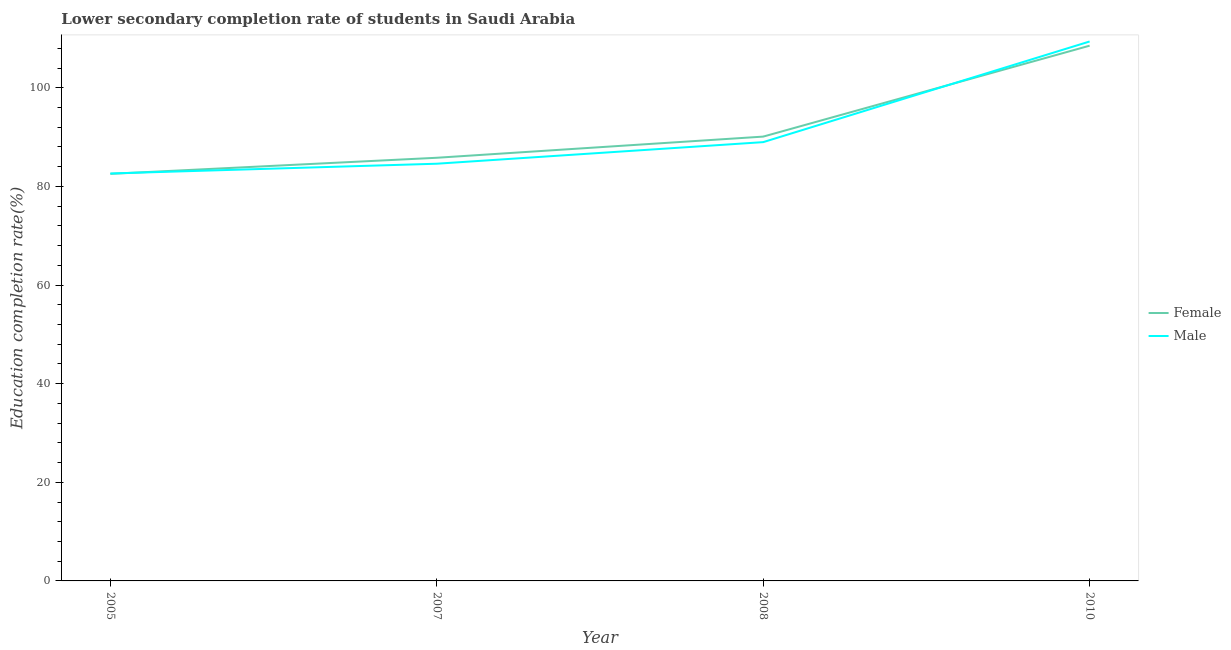How many different coloured lines are there?
Offer a terse response. 2. What is the education completion rate of male students in 2005?
Make the answer very short. 82.63. Across all years, what is the maximum education completion rate of female students?
Keep it short and to the point. 108.54. Across all years, what is the minimum education completion rate of female students?
Ensure brevity in your answer.  82.55. In which year was the education completion rate of female students minimum?
Ensure brevity in your answer.  2005. What is the total education completion rate of female students in the graph?
Your response must be concise. 367.01. What is the difference between the education completion rate of male students in 2007 and that in 2008?
Give a very brief answer. -4.38. What is the difference between the education completion rate of female students in 2007 and the education completion rate of male students in 2008?
Make the answer very short. -3.17. What is the average education completion rate of male students per year?
Provide a succinct answer. 91.4. In the year 2005, what is the difference between the education completion rate of female students and education completion rate of male students?
Your answer should be compact. -0.08. In how many years, is the education completion rate of female students greater than 24 %?
Keep it short and to the point. 4. What is the ratio of the education completion rate of male students in 2005 to that in 2007?
Your answer should be very brief. 0.98. What is the difference between the highest and the second highest education completion rate of female students?
Provide a succinct answer. 18.44. What is the difference between the highest and the lowest education completion rate of female students?
Offer a very short reply. 25.99. Is the sum of the education completion rate of female students in 2007 and 2008 greater than the maximum education completion rate of male students across all years?
Provide a short and direct response. Yes. Is the education completion rate of female students strictly greater than the education completion rate of male students over the years?
Provide a short and direct response. No. What is the difference between two consecutive major ticks on the Y-axis?
Your response must be concise. 20. Are the values on the major ticks of Y-axis written in scientific E-notation?
Provide a succinct answer. No. Does the graph contain any zero values?
Make the answer very short. No. Where does the legend appear in the graph?
Provide a short and direct response. Center right. How are the legend labels stacked?
Your answer should be compact. Vertical. What is the title of the graph?
Offer a terse response. Lower secondary completion rate of students in Saudi Arabia. What is the label or title of the X-axis?
Keep it short and to the point. Year. What is the label or title of the Y-axis?
Ensure brevity in your answer.  Education completion rate(%). What is the Education completion rate(%) in Female in 2005?
Offer a terse response. 82.55. What is the Education completion rate(%) in Male in 2005?
Your response must be concise. 82.63. What is the Education completion rate(%) of Female in 2007?
Provide a short and direct response. 85.81. What is the Education completion rate(%) in Male in 2007?
Offer a terse response. 84.61. What is the Education completion rate(%) in Female in 2008?
Offer a terse response. 90.1. What is the Education completion rate(%) of Male in 2008?
Provide a succinct answer. 88.98. What is the Education completion rate(%) in Female in 2010?
Offer a very short reply. 108.54. What is the Education completion rate(%) in Male in 2010?
Provide a short and direct response. 109.39. Across all years, what is the maximum Education completion rate(%) in Female?
Keep it short and to the point. 108.54. Across all years, what is the maximum Education completion rate(%) of Male?
Give a very brief answer. 109.39. Across all years, what is the minimum Education completion rate(%) of Female?
Make the answer very short. 82.55. Across all years, what is the minimum Education completion rate(%) in Male?
Offer a terse response. 82.63. What is the total Education completion rate(%) of Female in the graph?
Keep it short and to the point. 367.01. What is the total Education completion rate(%) of Male in the graph?
Offer a very short reply. 365.6. What is the difference between the Education completion rate(%) of Female in 2005 and that in 2007?
Provide a succinct answer. -3.26. What is the difference between the Education completion rate(%) in Male in 2005 and that in 2007?
Provide a succinct answer. -1.98. What is the difference between the Education completion rate(%) of Female in 2005 and that in 2008?
Provide a succinct answer. -7.56. What is the difference between the Education completion rate(%) of Male in 2005 and that in 2008?
Keep it short and to the point. -6.36. What is the difference between the Education completion rate(%) of Female in 2005 and that in 2010?
Give a very brief answer. -25.99. What is the difference between the Education completion rate(%) of Male in 2005 and that in 2010?
Your answer should be very brief. -26.77. What is the difference between the Education completion rate(%) in Female in 2007 and that in 2008?
Provide a short and direct response. -4.29. What is the difference between the Education completion rate(%) of Male in 2007 and that in 2008?
Provide a succinct answer. -4.38. What is the difference between the Education completion rate(%) of Female in 2007 and that in 2010?
Keep it short and to the point. -22.73. What is the difference between the Education completion rate(%) in Male in 2007 and that in 2010?
Your answer should be very brief. -24.79. What is the difference between the Education completion rate(%) of Female in 2008 and that in 2010?
Your answer should be very brief. -18.44. What is the difference between the Education completion rate(%) of Male in 2008 and that in 2010?
Your answer should be very brief. -20.41. What is the difference between the Education completion rate(%) of Female in 2005 and the Education completion rate(%) of Male in 2007?
Offer a terse response. -2.06. What is the difference between the Education completion rate(%) in Female in 2005 and the Education completion rate(%) in Male in 2008?
Ensure brevity in your answer.  -6.43. What is the difference between the Education completion rate(%) of Female in 2005 and the Education completion rate(%) of Male in 2010?
Provide a short and direct response. -26.84. What is the difference between the Education completion rate(%) of Female in 2007 and the Education completion rate(%) of Male in 2008?
Keep it short and to the point. -3.17. What is the difference between the Education completion rate(%) of Female in 2007 and the Education completion rate(%) of Male in 2010?
Your answer should be compact. -23.58. What is the difference between the Education completion rate(%) in Female in 2008 and the Education completion rate(%) in Male in 2010?
Offer a terse response. -19.29. What is the average Education completion rate(%) in Female per year?
Give a very brief answer. 91.75. What is the average Education completion rate(%) of Male per year?
Your response must be concise. 91.4. In the year 2005, what is the difference between the Education completion rate(%) in Female and Education completion rate(%) in Male?
Keep it short and to the point. -0.08. In the year 2007, what is the difference between the Education completion rate(%) of Female and Education completion rate(%) of Male?
Make the answer very short. 1.21. In the year 2008, what is the difference between the Education completion rate(%) in Female and Education completion rate(%) in Male?
Your answer should be compact. 1.12. In the year 2010, what is the difference between the Education completion rate(%) in Female and Education completion rate(%) in Male?
Your response must be concise. -0.85. What is the ratio of the Education completion rate(%) of Female in 2005 to that in 2007?
Make the answer very short. 0.96. What is the ratio of the Education completion rate(%) of Male in 2005 to that in 2007?
Give a very brief answer. 0.98. What is the ratio of the Education completion rate(%) in Female in 2005 to that in 2008?
Your response must be concise. 0.92. What is the ratio of the Education completion rate(%) in Female in 2005 to that in 2010?
Your response must be concise. 0.76. What is the ratio of the Education completion rate(%) in Male in 2005 to that in 2010?
Provide a succinct answer. 0.76. What is the ratio of the Education completion rate(%) in Female in 2007 to that in 2008?
Your answer should be compact. 0.95. What is the ratio of the Education completion rate(%) in Male in 2007 to that in 2008?
Offer a very short reply. 0.95. What is the ratio of the Education completion rate(%) of Female in 2007 to that in 2010?
Keep it short and to the point. 0.79. What is the ratio of the Education completion rate(%) of Male in 2007 to that in 2010?
Your answer should be very brief. 0.77. What is the ratio of the Education completion rate(%) of Female in 2008 to that in 2010?
Make the answer very short. 0.83. What is the ratio of the Education completion rate(%) in Male in 2008 to that in 2010?
Offer a very short reply. 0.81. What is the difference between the highest and the second highest Education completion rate(%) in Female?
Ensure brevity in your answer.  18.44. What is the difference between the highest and the second highest Education completion rate(%) in Male?
Your response must be concise. 20.41. What is the difference between the highest and the lowest Education completion rate(%) in Female?
Keep it short and to the point. 25.99. What is the difference between the highest and the lowest Education completion rate(%) in Male?
Keep it short and to the point. 26.77. 